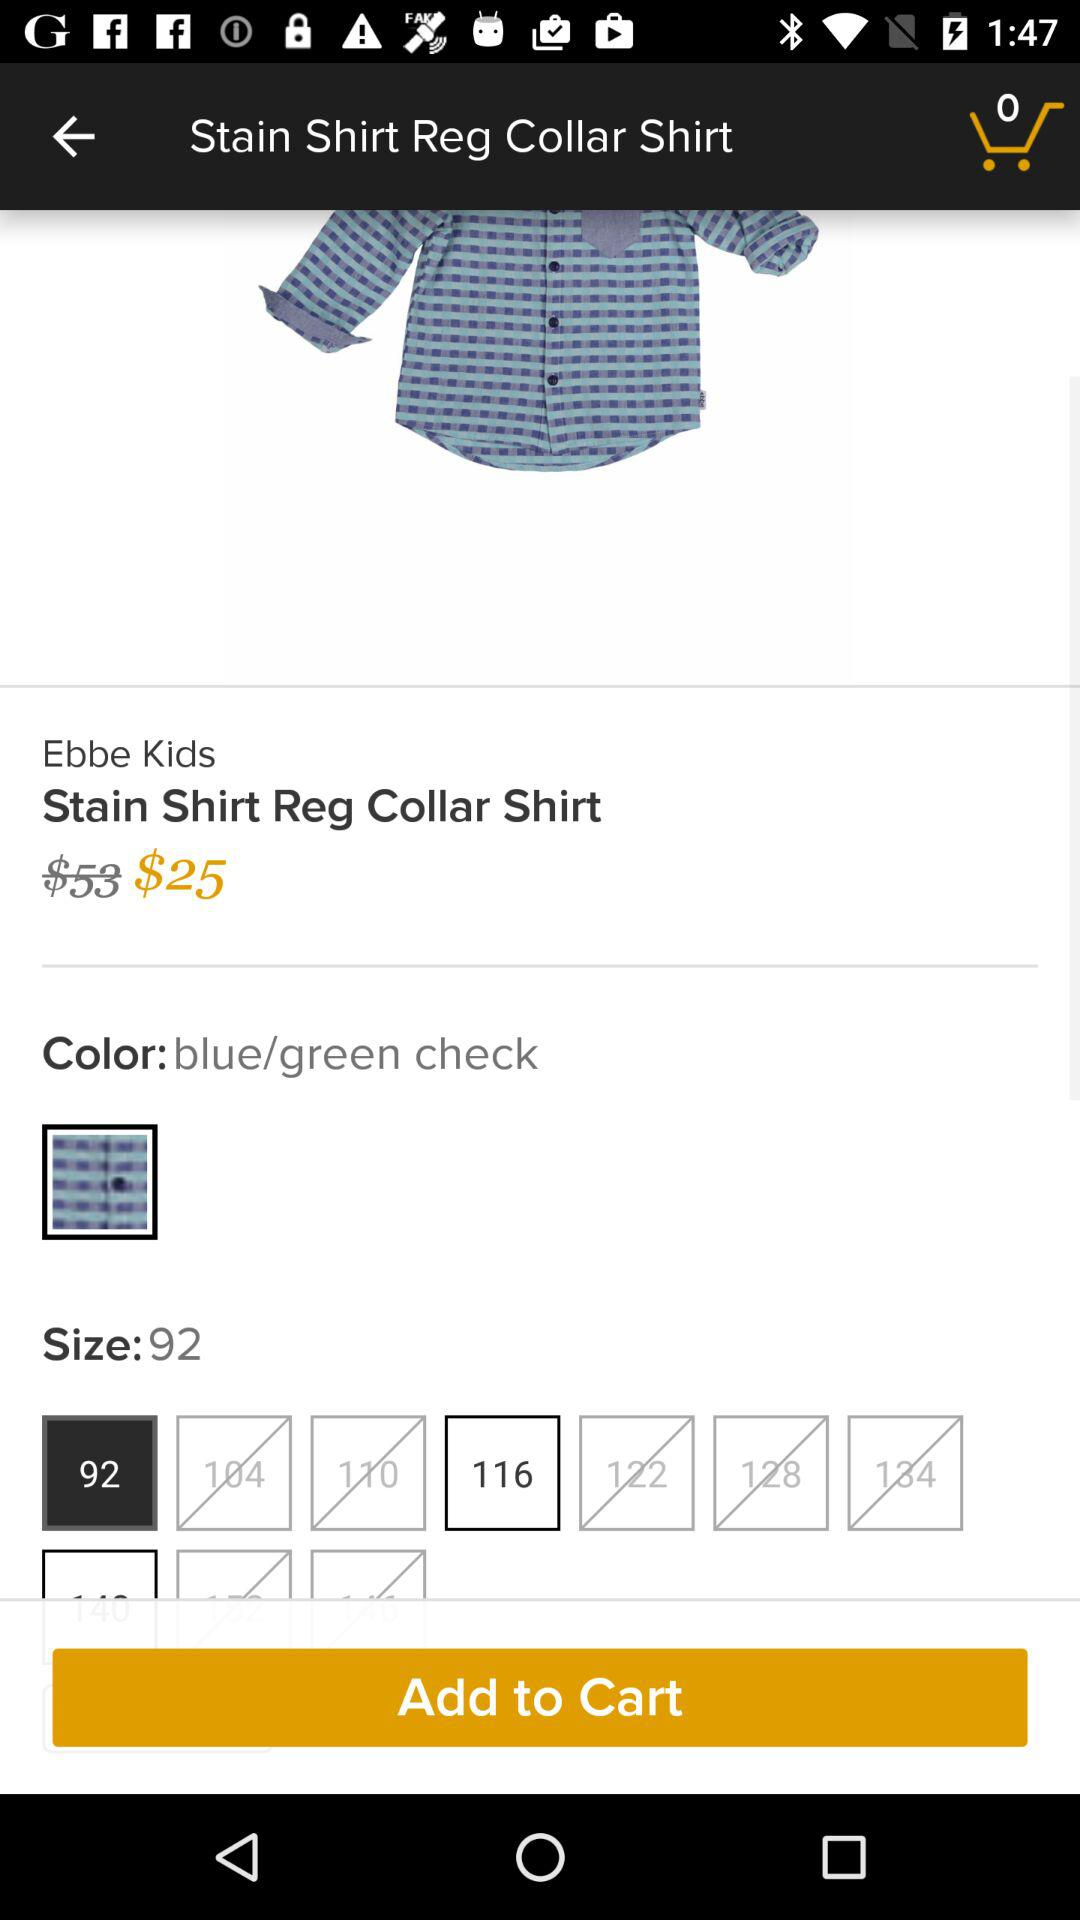How much is the original price of the shirt?
Answer the question using a single word or phrase. $53 